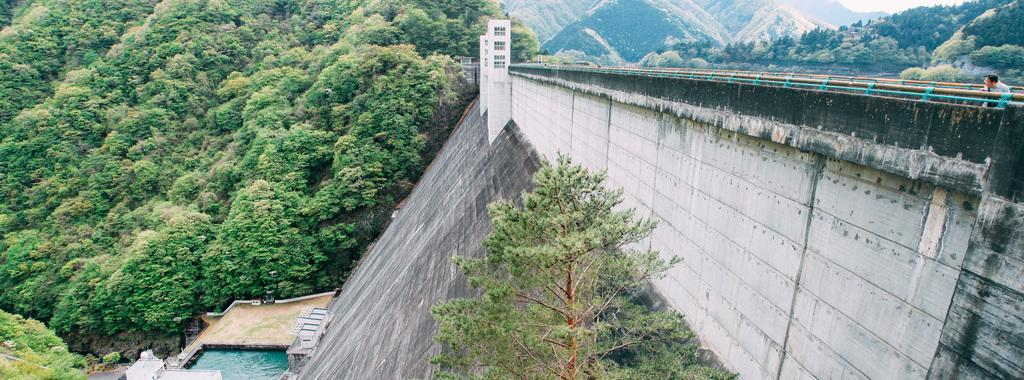What type of natural formation can be seen in the image? There are mountains in the image. What other natural elements are present in the image? There are trees and water visible in the image. Can you describe the terrain in the image? There is a slope in the image. Are there any man-made structures visible in the image? Yes, there are windows and rods in the image. Is there any sign of human presence in the image? Yes, there is a person visible at the backside of the roads. Can you tell me how many giraffes are present at the party in the image? There are no giraffes or parties present in the image; it features mountains, trees, water, a slope, windows, rods, and a person. How many chickens can be seen walking around near the water in the image? There are no chickens present in the image; it features mountains, trees, water, a slope, windows, rods, and a person. 